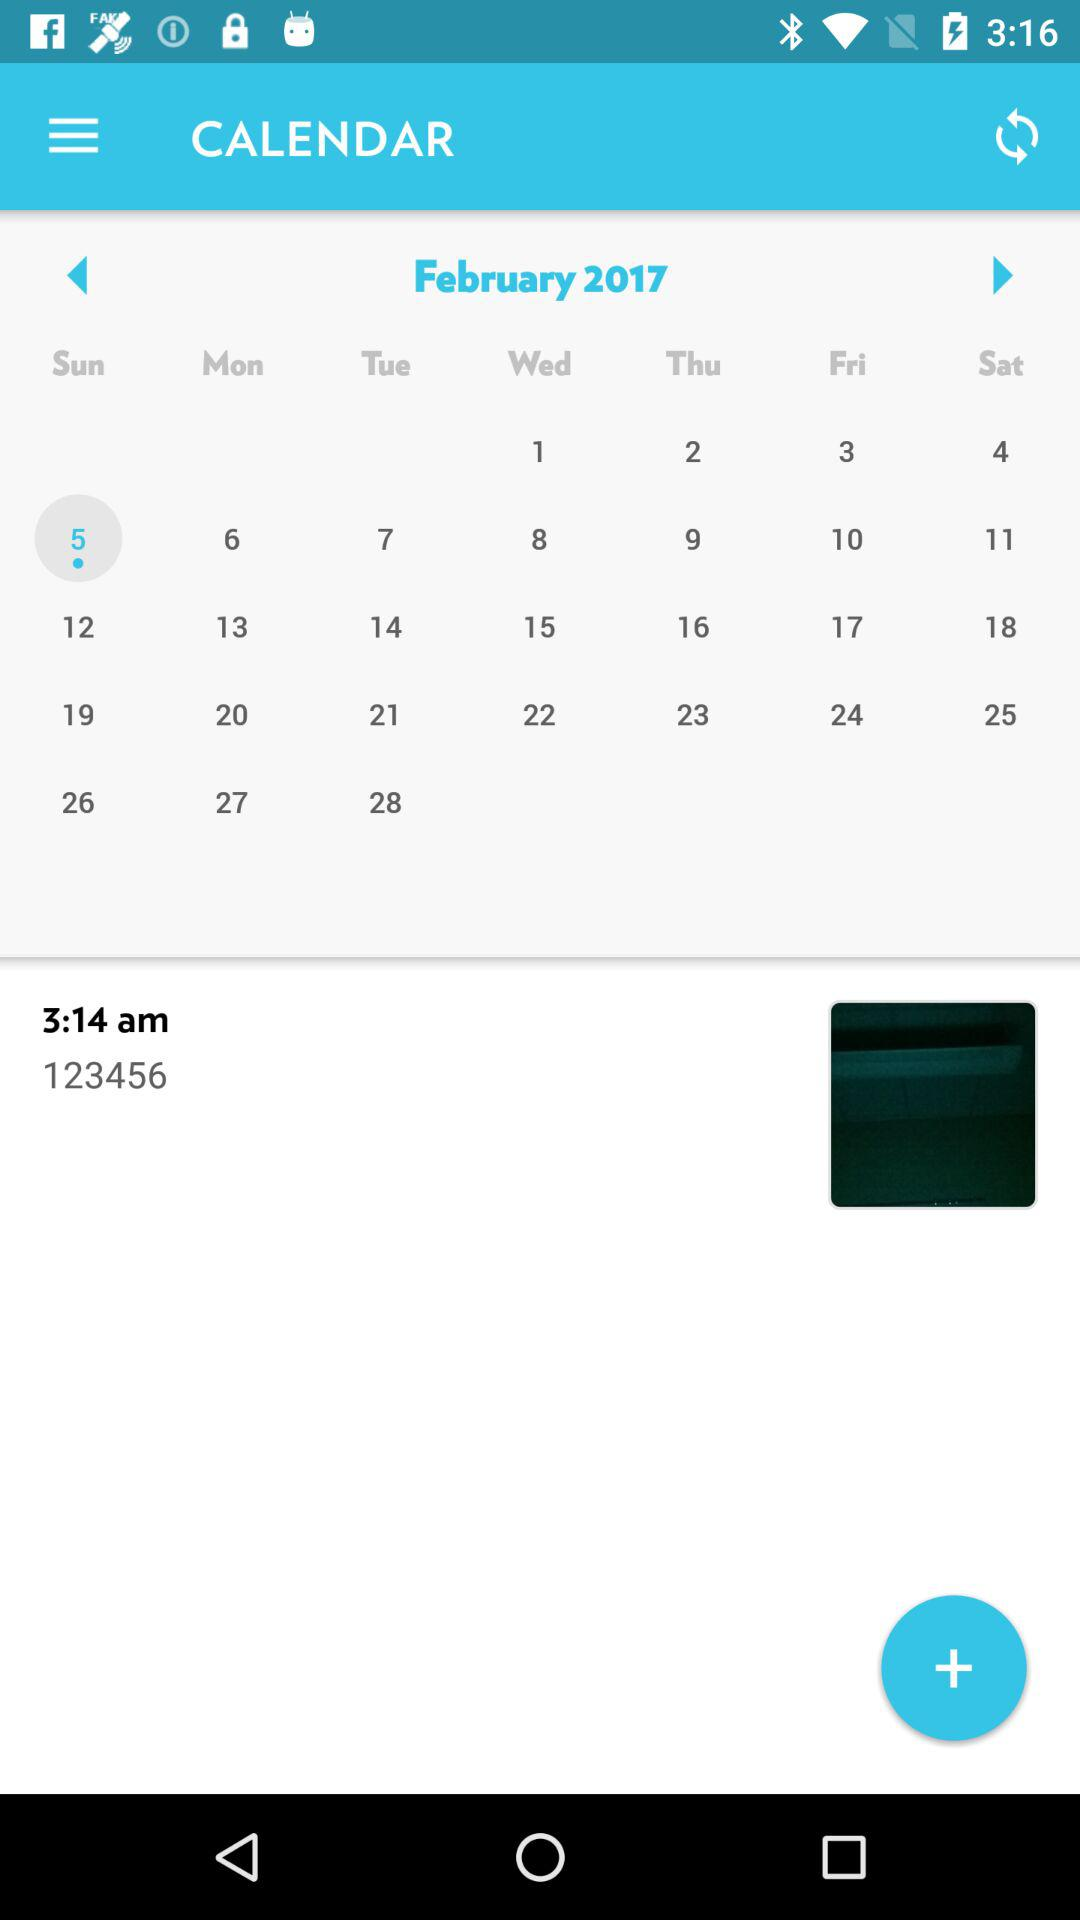What is the year? The year is 2017. 